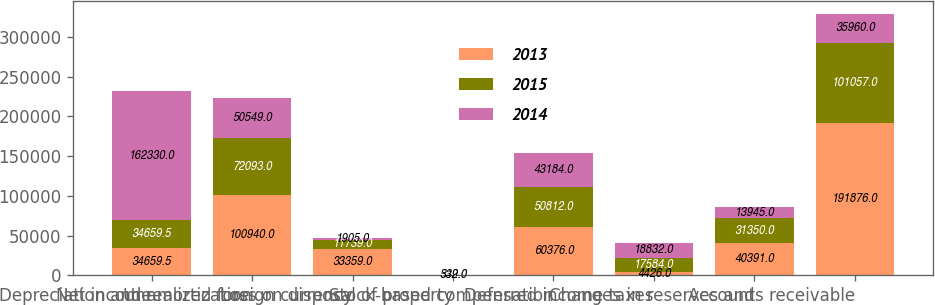Convert chart. <chart><loc_0><loc_0><loc_500><loc_500><stacked_bar_chart><ecel><fcel>Net income<fcel>Depreciation and amortization<fcel>Unrealized foreign currency<fcel>Loss on disposal of property<fcel>Stock-based compensation<fcel>Deferred income taxes<fcel>Changes in reserves and<fcel>Accounts receivable<nl><fcel>2013<fcel>34659.5<fcel>100940<fcel>33359<fcel>549<fcel>60376<fcel>4426<fcel>40391<fcel>191876<nl><fcel>2015<fcel>34659.5<fcel>72093<fcel>11739<fcel>261<fcel>50812<fcel>17584<fcel>31350<fcel>101057<nl><fcel>2014<fcel>162330<fcel>50549<fcel>1905<fcel>332<fcel>43184<fcel>18832<fcel>13945<fcel>35960<nl></chart> 